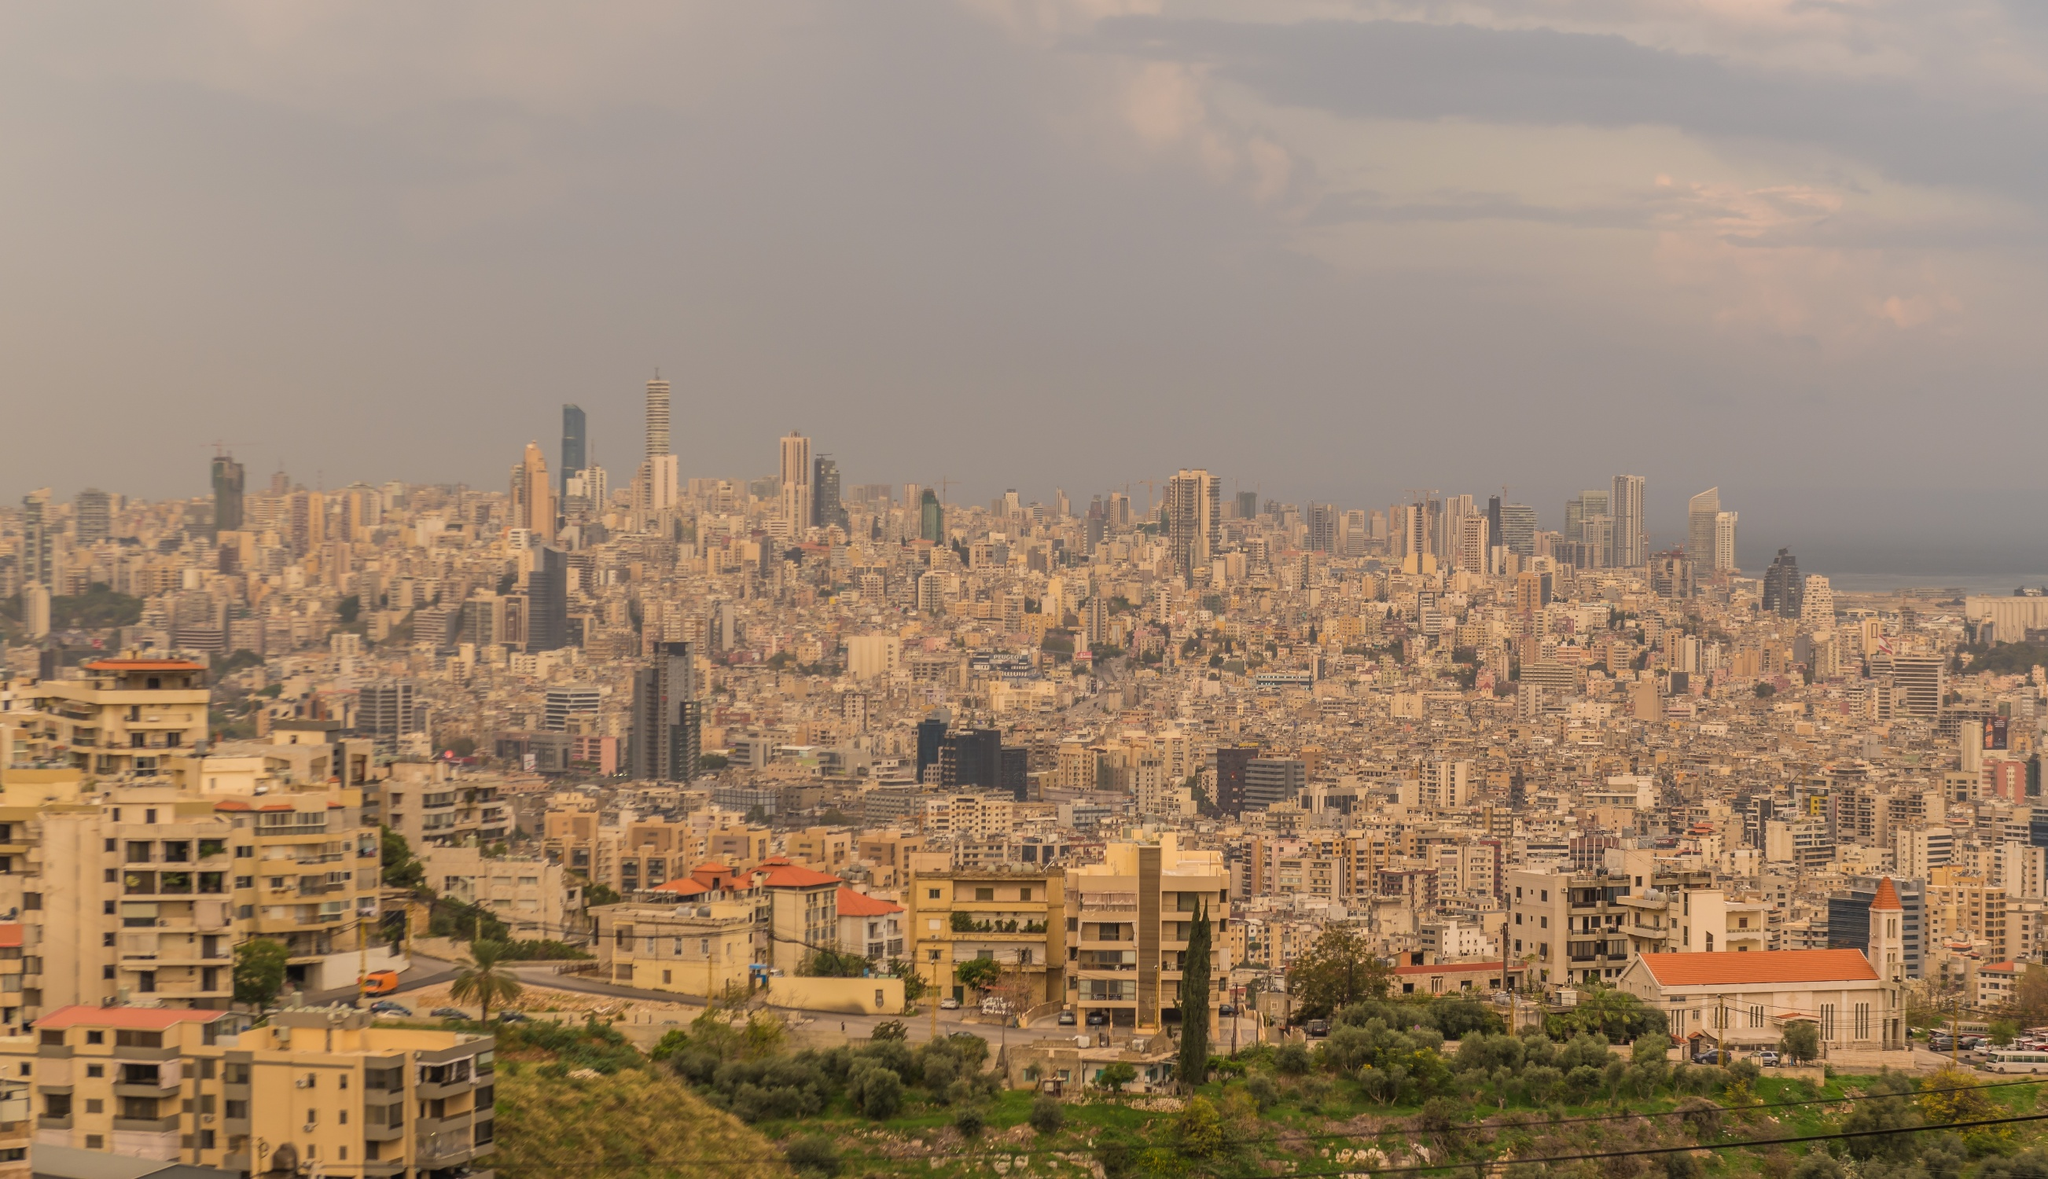Can you briefly explain the geographical layout of Beirut in this image? Certainly! This image showcases Beirut’s coastal positioning along the Mediterranean Sea. The city is sprawling with dense urban structures stretching towards the sea to the north. Hills can be seen to the south, indicating how the city has developed around its natural topography. This geographical layout emphasizes Beirut's strategic historical importance as a port and cultural hub. 